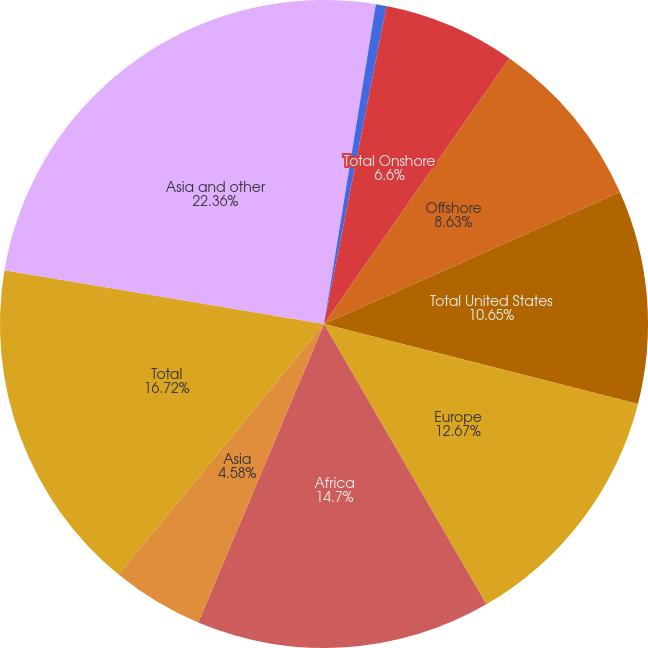Convert chart. <chart><loc_0><loc_0><loc_500><loc_500><pie_chart><fcel>Bakken<fcel>Other Onshore<fcel>Total Onshore<fcel>Offshore<fcel>Total United States<fcel>Europe<fcel>Africa<fcel>Asia<fcel>Total<fcel>Asia and other<nl><fcel>2.56%<fcel>0.53%<fcel>6.6%<fcel>8.63%<fcel>10.65%<fcel>12.67%<fcel>14.7%<fcel>4.58%<fcel>16.72%<fcel>22.35%<nl></chart> 